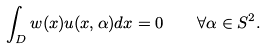Convert formula to latex. <formula><loc_0><loc_0><loc_500><loc_500>\int _ { D } w ( x ) u ( x , \alpha ) d x = 0 \quad \forall \alpha \in S ^ { 2 } .</formula> 